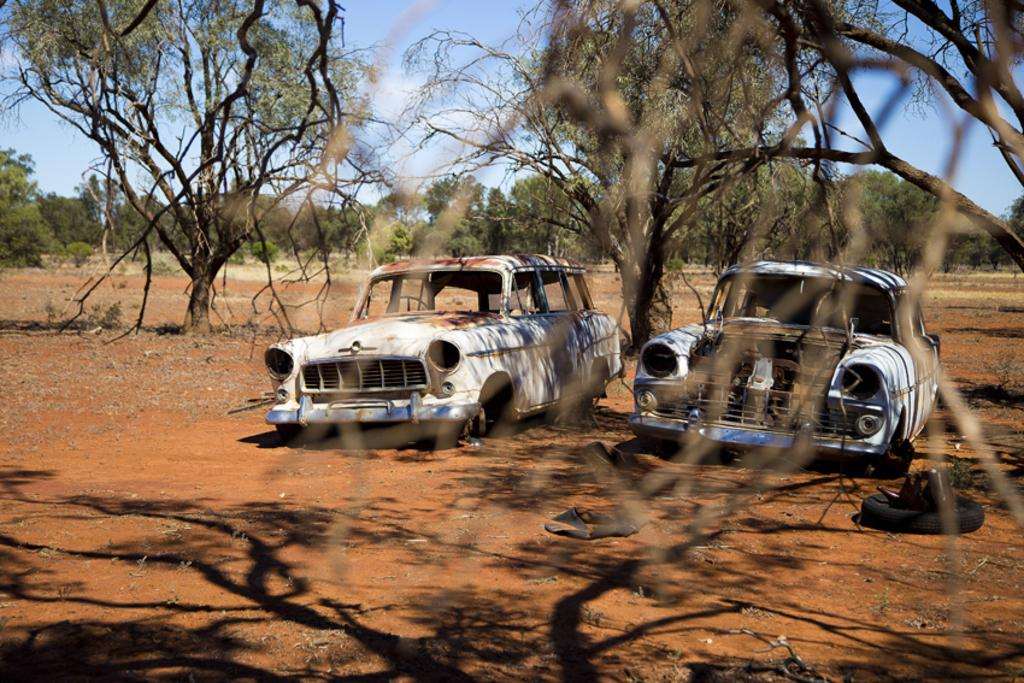What are the main subjects in the center of the image? There are two old dusty cars in the center of the image. What can be seen in the background of the image? There are trees and the sky visible in the background of the image. What is the condition of the car in the image from the year 2000? There is no car from the year 2000 mentioned in the image, and the condition of the cars cannot be determined from the provided facts. 